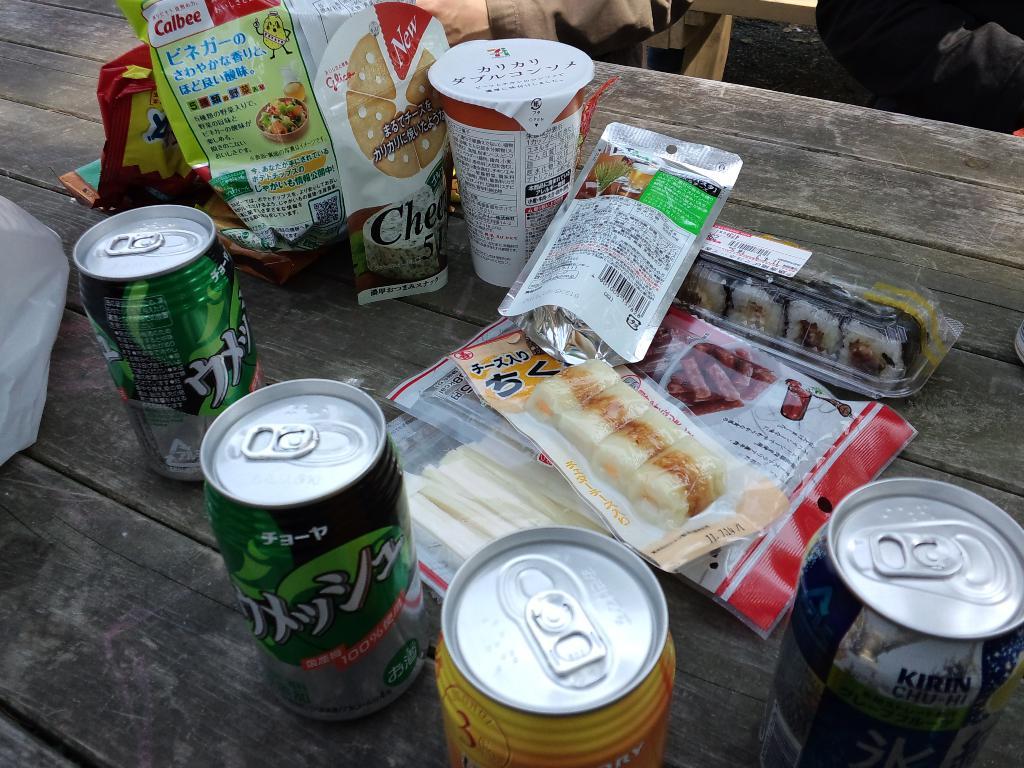What country are the snacks from?
Provide a short and direct response. Unanswerable. Is the second snack at the top new?
Ensure brevity in your answer.  Yes. 